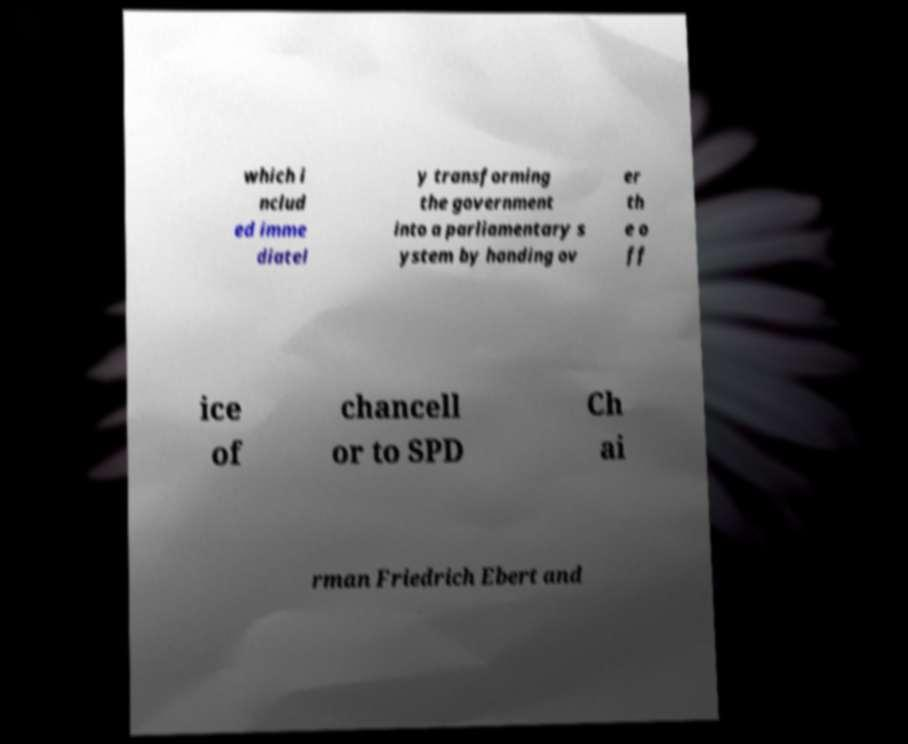Could you extract and type out the text from this image? which i nclud ed imme diatel y transforming the government into a parliamentary s ystem by handing ov er th e o ff ice of chancell or to SPD Ch ai rman Friedrich Ebert and 